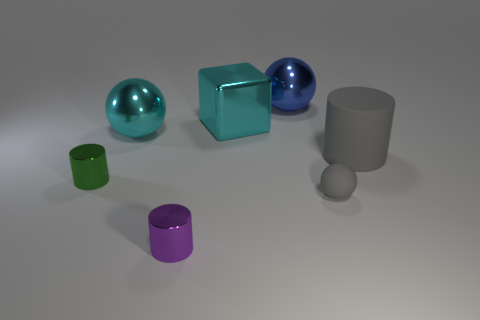There is a rubber thing that is behind the tiny metal cylinder that is behind the tiny thing right of the blue metallic object; what is its color?
Ensure brevity in your answer.  Gray. Is the small rubber thing the same shape as the purple shiny thing?
Provide a succinct answer. No. There is a thing that is made of the same material as the gray ball; what is its color?
Make the answer very short. Gray. How many things are either things that are on the left side of the cyan shiny sphere or big blue rubber cylinders?
Your response must be concise. 1. What size is the purple metal object on the left side of the matte cylinder?
Your response must be concise. Small. There is a purple metal cylinder; is its size the same as the object that is on the right side of the small gray ball?
Ensure brevity in your answer.  No. There is a tiny shiny object that is in front of the metal cylinder that is left of the purple object; what color is it?
Provide a short and direct response. Purple. Are there the same number of red balls and cyan balls?
Keep it short and to the point. No. What number of other objects are the same color as the cube?
Your answer should be compact. 1. What size is the matte cylinder?
Give a very brief answer. Large. 